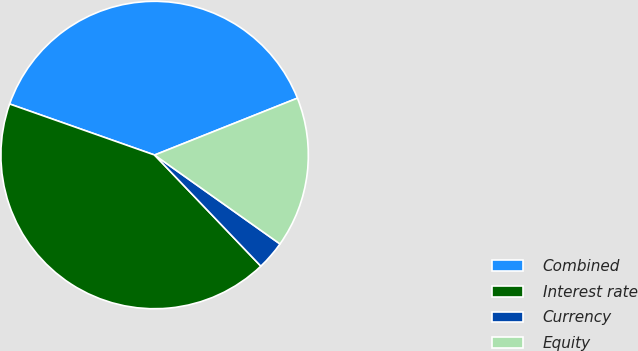<chart> <loc_0><loc_0><loc_500><loc_500><pie_chart><fcel>Combined<fcel>Interest rate<fcel>Currency<fcel>Equity<nl><fcel>38.58%<fcel>42.53%<fcel>3.04%<fcel>15.85%<nl></chart> 